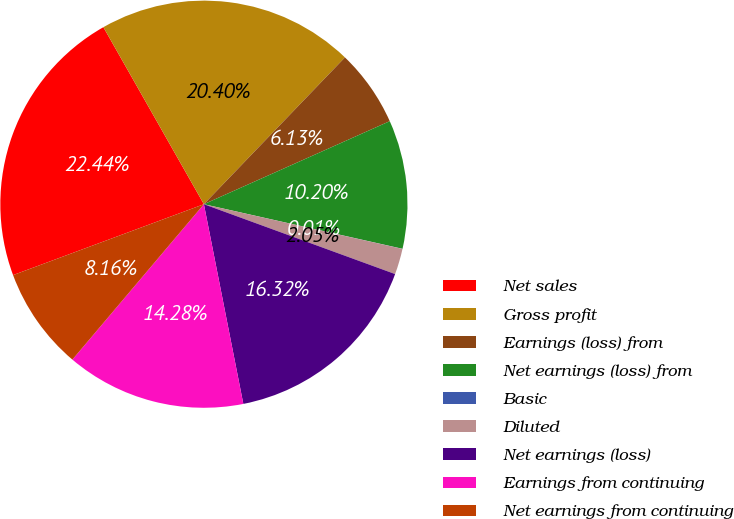<chart> <loc_0><loc_0><loc_500><loc_500><pie_chart><fcel>Net sales<fcel>Gross profit<fcel>Earnings (loss) from<fcel>Net earnings (loss) from<fcel>Basic<fcel>Diluted<fcel>Net earnings (loss)<fcel>Earnings from continuing<fcel>Net earnings from continuing<nl><fcel>22.44%<fcel>20.4%<fcel>6.13%<fcel>10.2%<fcel>0.01%<fcel>2.05%<fcel>16.32%<fcel>14.28%<fcel>8.16%<nl></chart> 